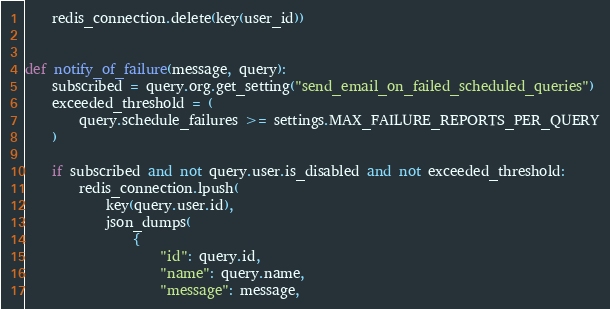<code> <loc_0><loc_0><loc_500><loc_500><_Python_>    redis_connection.delete(key(user_id))


def notify_of_failure(message, query):
    subscribed = query.org.get_setting("send_email_on_failed_scheduled_queries")
    exceeded_threshold = (
        query.schedule_failures >= settings.MAX_FAILURE_REPORTS_PER_QUERY
    )

    if subscribed and not query.user.is_disabled and not exceeded_threshold:
        redis_connection.lpush(
            key(query.user.id),
            json_dumps(
                {
                    "id": query.id,
                    "name": query.name,
                    "message": message,</code> 